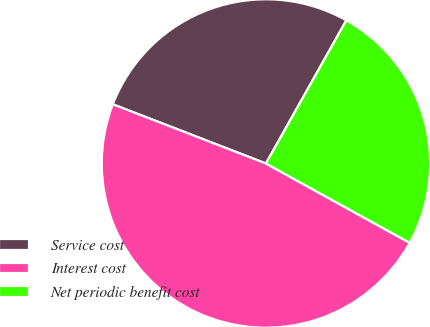<chart> <loc_0><loc_0><loc_500><loc_500><pie_chart><fcel>Service cost<fcel>Interest cost<fcel>Net periodic benefit cost<nl><fcel>27.27%<fcel>47.85%<fcel>24.88%<nl></chart> 